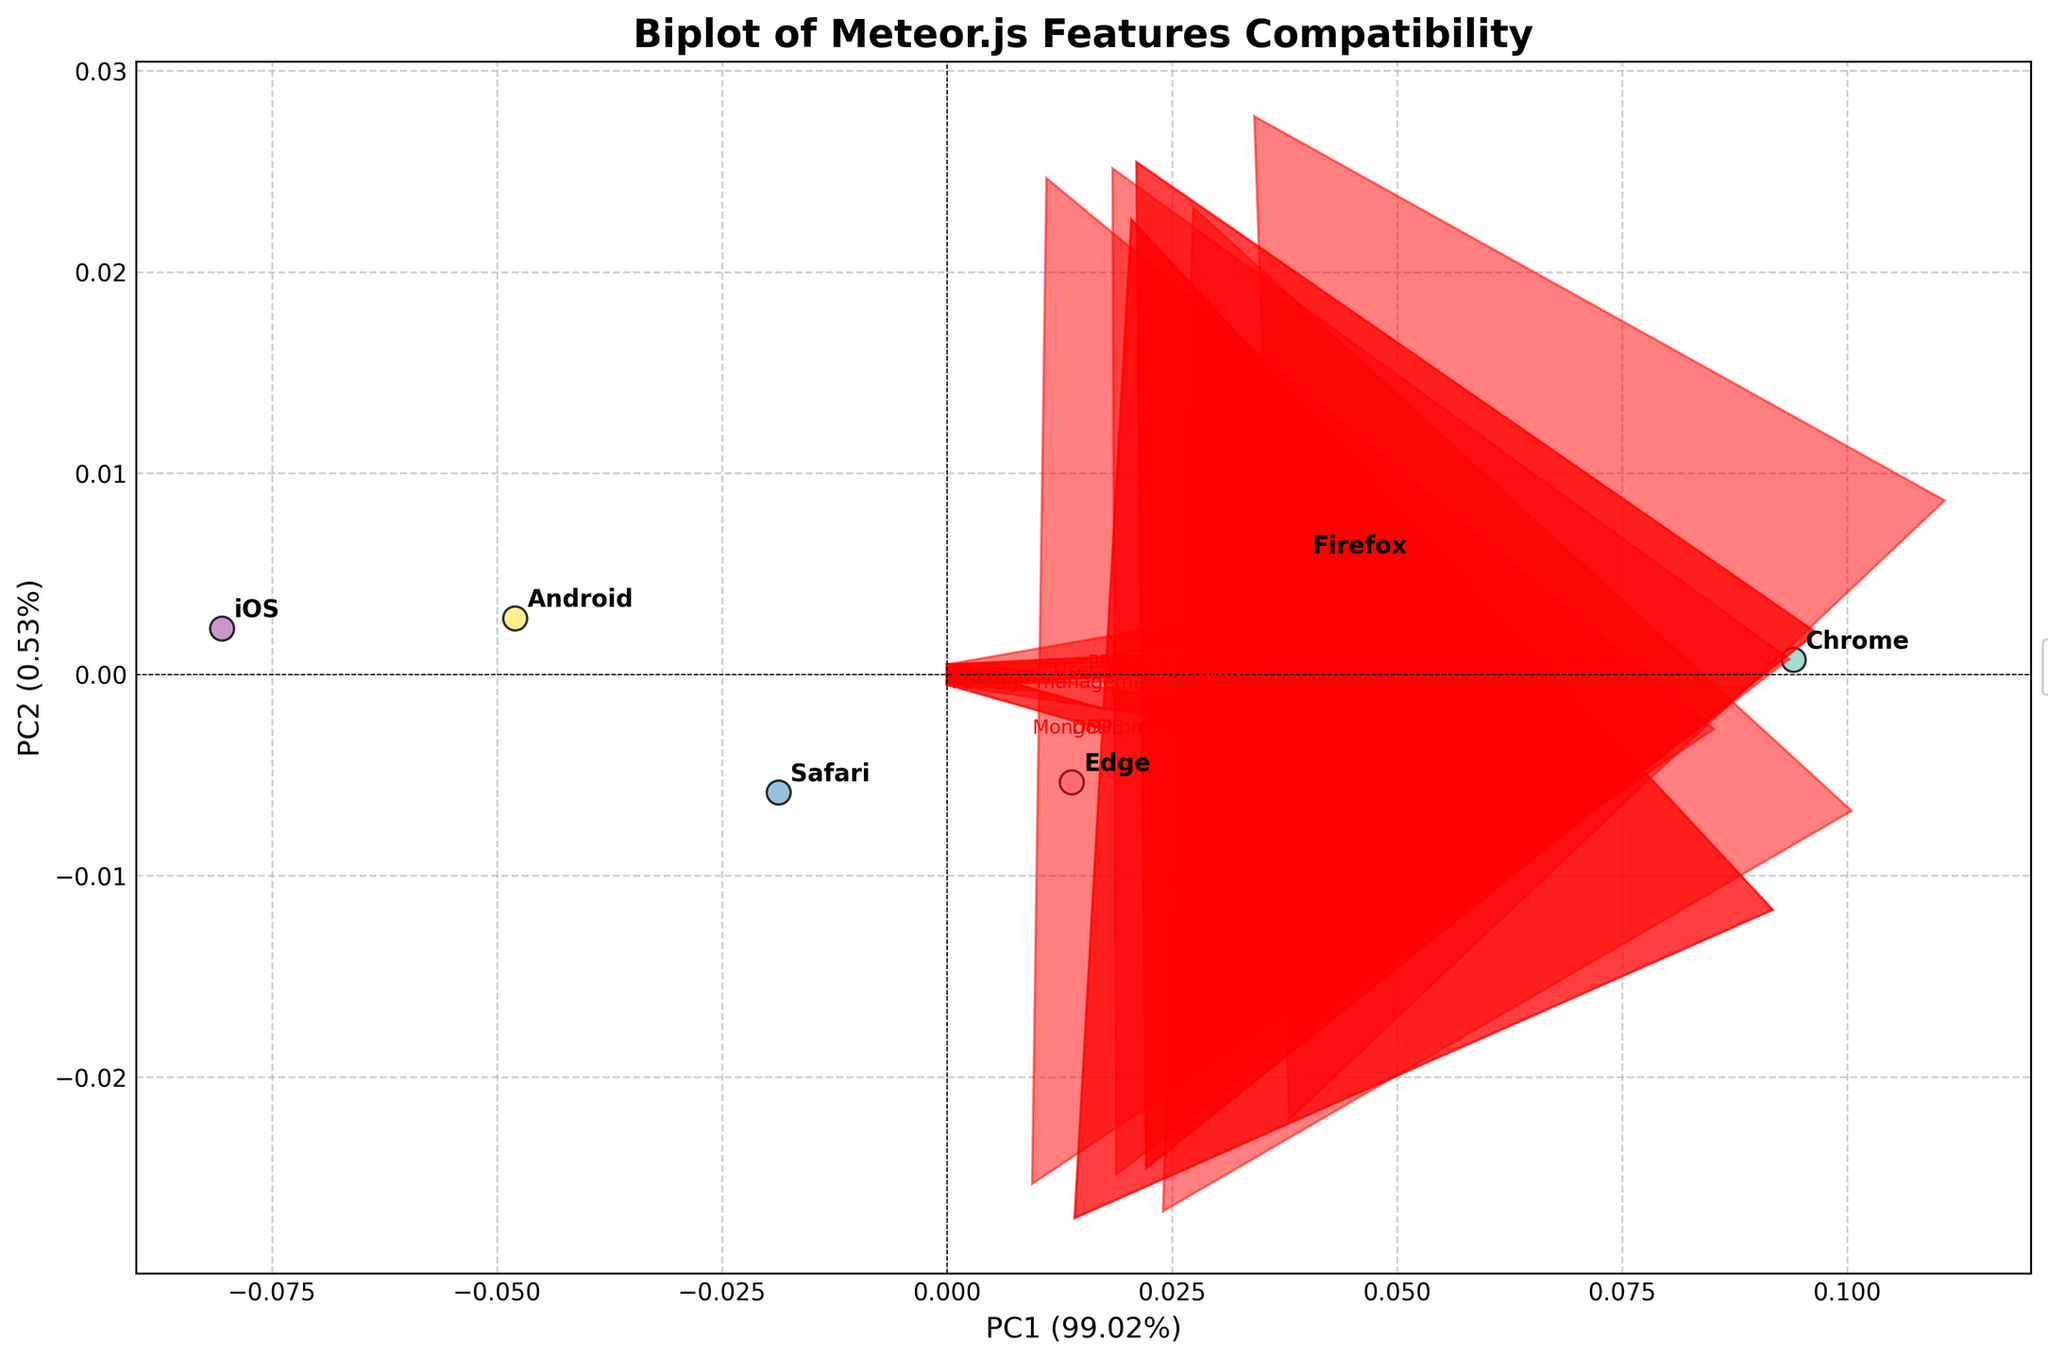What is the title of the figure? The title is located at the top of the plot. It usually describes what the figure represents. In this case, it states the main focus of the plot.
Answer: Biplot of Meteor.js Features Compatibility How many features are represented by vectors in the plot? The number of vectors labeled with features in the plot corresponds to the number of features represented. By counting these vectors, we can determine the total number of features.
Answer: 8 Which browser/device is closest to the origin? By looking at the points plotted closest to the central point (0,0) in the PCA biplot, we can identify the browser/device that is closest to the origin.
Answer: Android What does the first principal component explain in terms of variance percentage? The axis label for the first principal component (PC1) includes the percentage of variance it explains from the original data. It is usually indicated in parentheses next to 'PC1'.
Answer: 57.87% Which feature is most positively correlated with PC1? To determine which feature is most positively correlated with the first principal component, look for the vector with the highest positive loading along the PC1 axis.
Answer: Package management Which two browsers/devices are plotted closest to each other? By observing the distances between the plotted points for different browsers/devices, we can identify the pair that is closest together.
Answer: Chrome and Firefox Which feature has the lowest influence on PC2? The influence of a feature on the second principal component is represented by the loading along the PC2 axis. The feature with the smallest loading vector along this axis has the lowest influence on PC2.
Answer: Hot code push Is the feature 'Reactive templates' more aligned with PC1 or PC2? By examining the direction of the vector for 'Reactive templates', determine if it points more towards the PC1 or PC2 axis.
Answer: PC1 Which feature vector points most directly towards the bottom-left quadrant of the plot? The feature vector pointing most directly towards the bottom-left quadrant will have both negative values for PC1 and PC2.
Answer: User authentication 